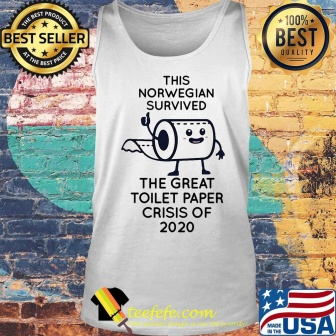Can you describe the main features of this image for me? The image features a white tank top displayed against a textured brick wall. It is adorned with a humorous cartoon illustrating a roll of toilet paper, depicted with human-like limbs, standing proudly. This visual pun commemorates 'The great toilet paper crisis of 2020' referring to the buying panic during the COVID-19 lockdowns. Above the illustration, the caption declares the wearer as a survivor of the event and includes a nod to Norwegian endurance. The tank top is marketed as a popular and high-quality item, evidenced by the 'best seller' and '100% best quality' badges. It suggests a blend of humor and nostalgia, making a playful commentary on a recent historical moment, likely appealing to online shoppers with a sense of humor about the shared experience. 